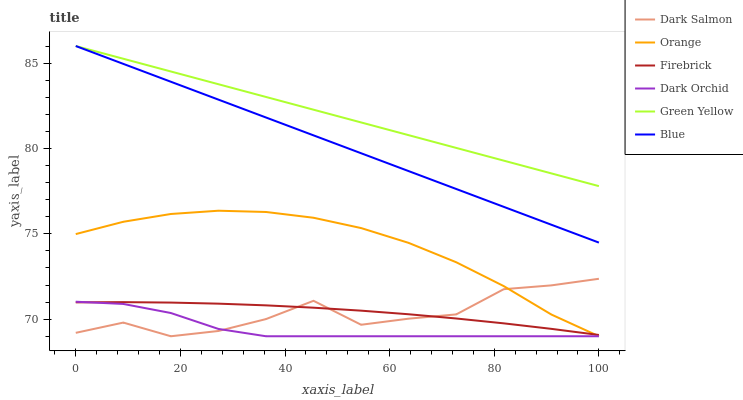Does Dark Orchid have the minimum area under the curve?
Answer yes or no. Yes. Does Green Yellow have the maximum area under the curve?
Answer yes or no. Yes. Does Firebrick have the minimum area under the curve?
Answer yes or no. No. Does Firebrick have the maximum area under the curve?
Answer yes or no. No. Is Blue the smoothest?
Answer yes or no. Yes. Is Dark Salmon the roughest?
Answer yes or no. Yes. Is Firebrick the smoothest?
Answer yes or no. No. Is Firebrick the roughest?
Answer yes or no. No. Does Dark Salmon have the lowest value?
Answer yes or no. Yes. Does Firebrick have the lowest value?
Answer yes or no. No. Does Green Yellow have the highest value?
Answer yes or no. Yes. Does Dark Salmon have the highest value?
Answer yes or no. No. Is Orange less than Blue?
Answer yes or no. Yes. Is Blue greater than Dark Orchid?
Answer yes or no. Yes. Does Dark Orchid intersect Orange?
Answer yes or no. Yes. Is Dark Orchid less than Orange?
Answer yes or no. No. Is Dark Orchid greater than Orange?
Answer yes or no. No. Does Orange intersect Blue?
Answer yes or no. No. 